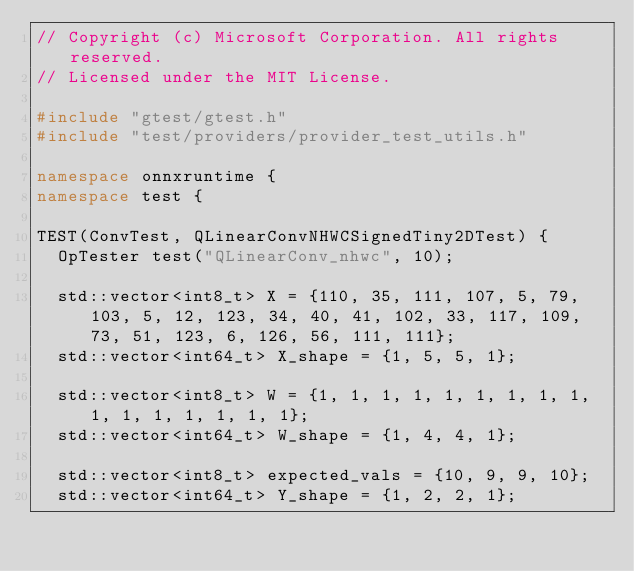<code> <loc_0><loc_0><loc_500><loc_500><_C++_>// Copyright (c) Microsoft Corporation. All rights reserved.
// Licensed under the MIT License.

#include "gtest/gtest.h"
#include "test/providers/provider_test_utils.h"

namespace onnxruntime {
namespace test {

TEST(ConvTest, QLinearConvNHWCSignedTiny2DTest) {
  OpTester test("QLinearConv_nhwc", 10);

  std::vector<int8_t> X = {110, 35, 111, 107, 5, 79, 103, 5, 12, 123, 34, 40, 41, 102, 33, 117, 109, 73, 51, 123, 6, 126, 56, 111, 111};
  std::vector<int64_t> X_shape = {1, 5, 5, 1};

  std::vector<int8_t> W = {1, 1, 1, 1, 1, 1, 1, 1, 1, 1, 1, 1, 1, 1, 1, 1};
  std::vector<int64_t> W_shape = {1, 4, 4, 1};

  std::vector<int8_t> expected_vals = {10, 9, 9, 10};
  std::vector<int64_t> Y_shape = {1, 2, 2, 1};
</code> 